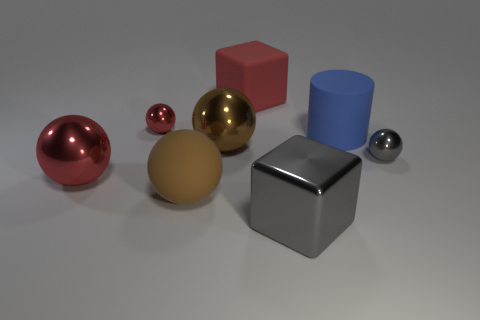There is a large thing that is the same color as the large matte sphere; what shape is it?
Offer a terse response. Sphere. Is the color of the big cube in front of the red block the same as the big rubber cylinder?
Your response must be concise. No. There is a big matte thing on the right side of the red matte cube; is its shape the same as the red object on the right side of the brown metal thing?
Your response must be concise. No. How big is the red rubber object that is behind the large red sphere?
Provide a succinct answer. Large. What is the size of the blue matte thing that is to the left of the small shiny thing to the right of the gray block?
Your answer should be very brief. Large. Is the number of gray cubes greater than the number of gray cylinders?
Offer a terse response. Yes. Are there more blue cylinders that are in front of the gray block than big rubber cubes to the left of the red rubber thing?
Provide a short and direct response. No. What size is the metal object that is right of the large red cube and on the left side of the tiny gray metallic object?
Make the answer very short. Large. How many brown metal cylinders have the same size as the red matte object?
Keep it short and to the point. 0. What is the material of the ball that is the same color as the shiny cube?
Ensure brevity in your answer.  Metal. 